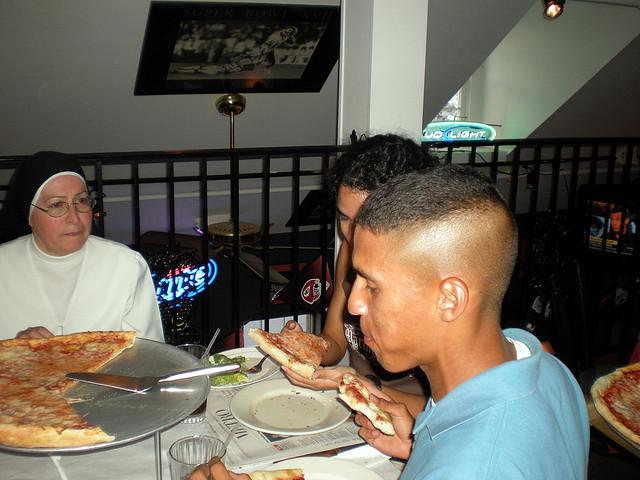How many pizzas have been taken from the pizza?
Give a very brief answer. 3. What is the woman looking at?
Quick response, please. Man. What type of religious person is the woman based on her outfit?
Short answer required. Nun. 